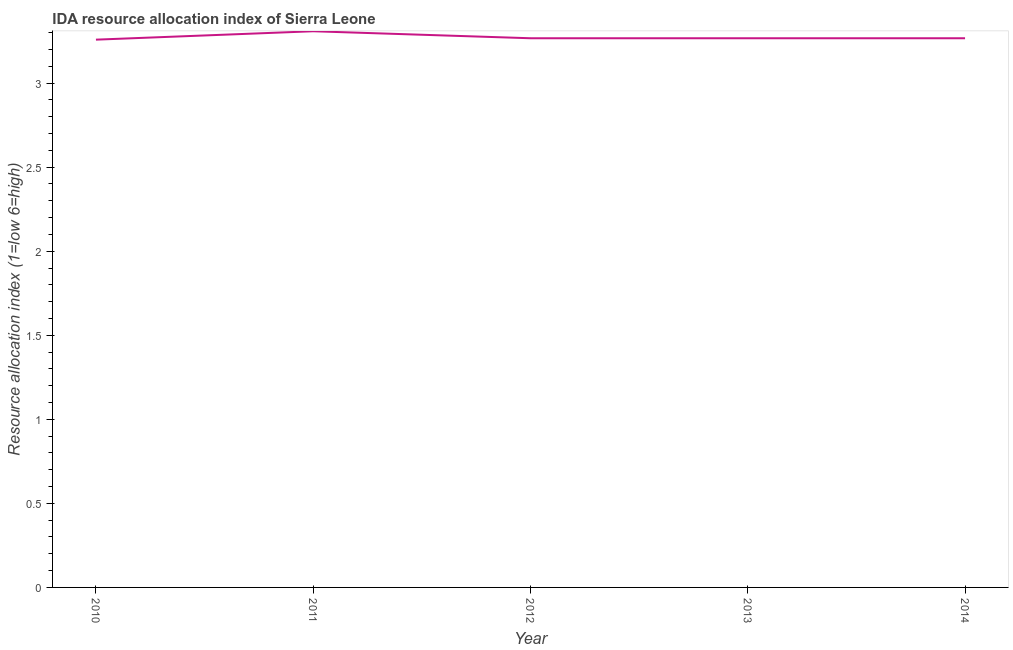What is the ida resource allocation index in 2013?
Your response must be concise. 3.27. Across all years, what is the maximum ida resource allocation index?
Provide a succinct answer. 3.31. Across all years, what is the minimum ida resource allocation index?
Provide a succinct answer. 3.26. In which year was the ida resource allocation index maximum?
Provide a succinct answer. 2011. In which year was the ida resource allocation index minimum?
Give a very brief answer. 2010. What is the sum of the ida resource allocation index?
Keep it short and to the point. 16.37. What is the difference between the ida resource allocation index in 2010 and 2014?
Provide a succinct answer. -0.01. What is the average ida resource allocation index per year?
Offer a very short reply. 3.27. What is the median ida resource allocation index?
Provide a short and direct response. 3.27. In how many years, is the ida resource allocation index greater than 3 ?
Provide a succinct answer. 5. Do a majority of the years between 2012 and 2014 (inclusive) have ida resource allocation index greater than 2.1 ?
Offer a terse response. Yes. What is the ratio of the ida resource allocation index in 2011 to that in 2013?
Your answer should be very brief. 1.01. Is the ida resource allocation index in 2011 less than that in 2013?
Provide a short and direct response. No. Is the difference between the ida resource allocation index in 2010 and 2014 greater than the difference between any two years?
Keep it short and to the point. No. What is the difference between the highest and the second highest ida resource allocation index?
Give a very brief answer. 0.04. Is the sum of the ida resource allocation index in 2010 and 2011 greater than the maximum ida resource allocation index across all years?
Provide a succinct answer. Yes. What is the difference between the highest and the lowest ida resource allocation index?
Make the answer very short. 0.05. In how many years, is the ida resource allocation index greater than the average ida resource allocation index taken over all years?
Provide a short and direct response. 1. How many lines are there?
Your answer should be very brief. 1. What is the difference between two consecutive major ticks on the Y-axis?
Your answer should be compact. 0.5. Does the graph contain any zero values?
Your response must be concise. No. What is the title of the graph?
Offer a very short reply. IDA resource allocation index of Sierra Leone. What is the label or title of the X-axis?
Make the answer very short. Year. What is the label or title of the Y-axis?
Provide a succinct answer. Resource allocation index (1=low 6=high). What is the Resource allocation index (1=low 6=high) in 2010?
Your answer should be compact. 3.26. What is the Resource allocation index (1=low 6=high) of 2011?
Offer a terse response. 3.31. What is the Resource allocation index (1=low 6=high) in 2012?
Provide a succinct answer. 3.27. What is the Resource allocation index (1=low 6=high) of 2013?
Offer a very short reply. 3.27. What is the Resource allocation index (1=low 6=high) in 2014?
Ensure brevity in your answer.  3.27. What is the difference between the Resource allocation index (1=low 6=high) in 2010 and 2011?
Provide a short and direct response. -0.05. What is the difference between the Resource allocation index (1=low 6=high) in 2010 and 2012?
Your answer should be compact. -0.01. What is the difference between the Resource allocation index (1=low 6=high) in 2010 and 2013?
Keep it short and to the point. -0.01. What is the difference between the Resource allocation index (1=low 6=high) in 2010 and 2014?
Provide a succinct answer. -0.01. What is the difference between the Resource allocation index (1=low 6=high) in 2011 and 2012?
Provide a short and direct response. 0.04. What is the difference between the Resource allocation index (1=low 6=high) in 2011 and 2013?
Make the answer very short. 0.04. What is the difference between the Resource allocation index (1=low 6=high) in 2011 and 2014?
Give a very brief answer. 0.04. What is the difference between the Resource allocation index (1=low 6=high) in 2012 and 2013?
Your answer should be very brief. 0. What is the difference between the Resource allocation index (1=low 6=high) in 2012 and 2014?
Make the answer very short. -0. What is the difference between the Resource allocation index (1=low 6=high) in 2013 and 2014?
Your answer should be compact. -0. What is the ratio of the Resource allocation index (1=low 6=high) in 2010 to that in 2013?
Give a very brief answer. 1. What is the ratio of the Resource allocation index (1=low 6=high) in 2011 to that in 2013?
Provide a short and direct response. 1.01. What is the ratio of the Resource allocation index (1=low 6=high) in 2012 to that in 2013?
Provide a short and direct response. 1. What is the ratio of the Resource allocation index (1=low 6=high) in 2013 to that in 2014?
Your answer should be very brief. 1. 